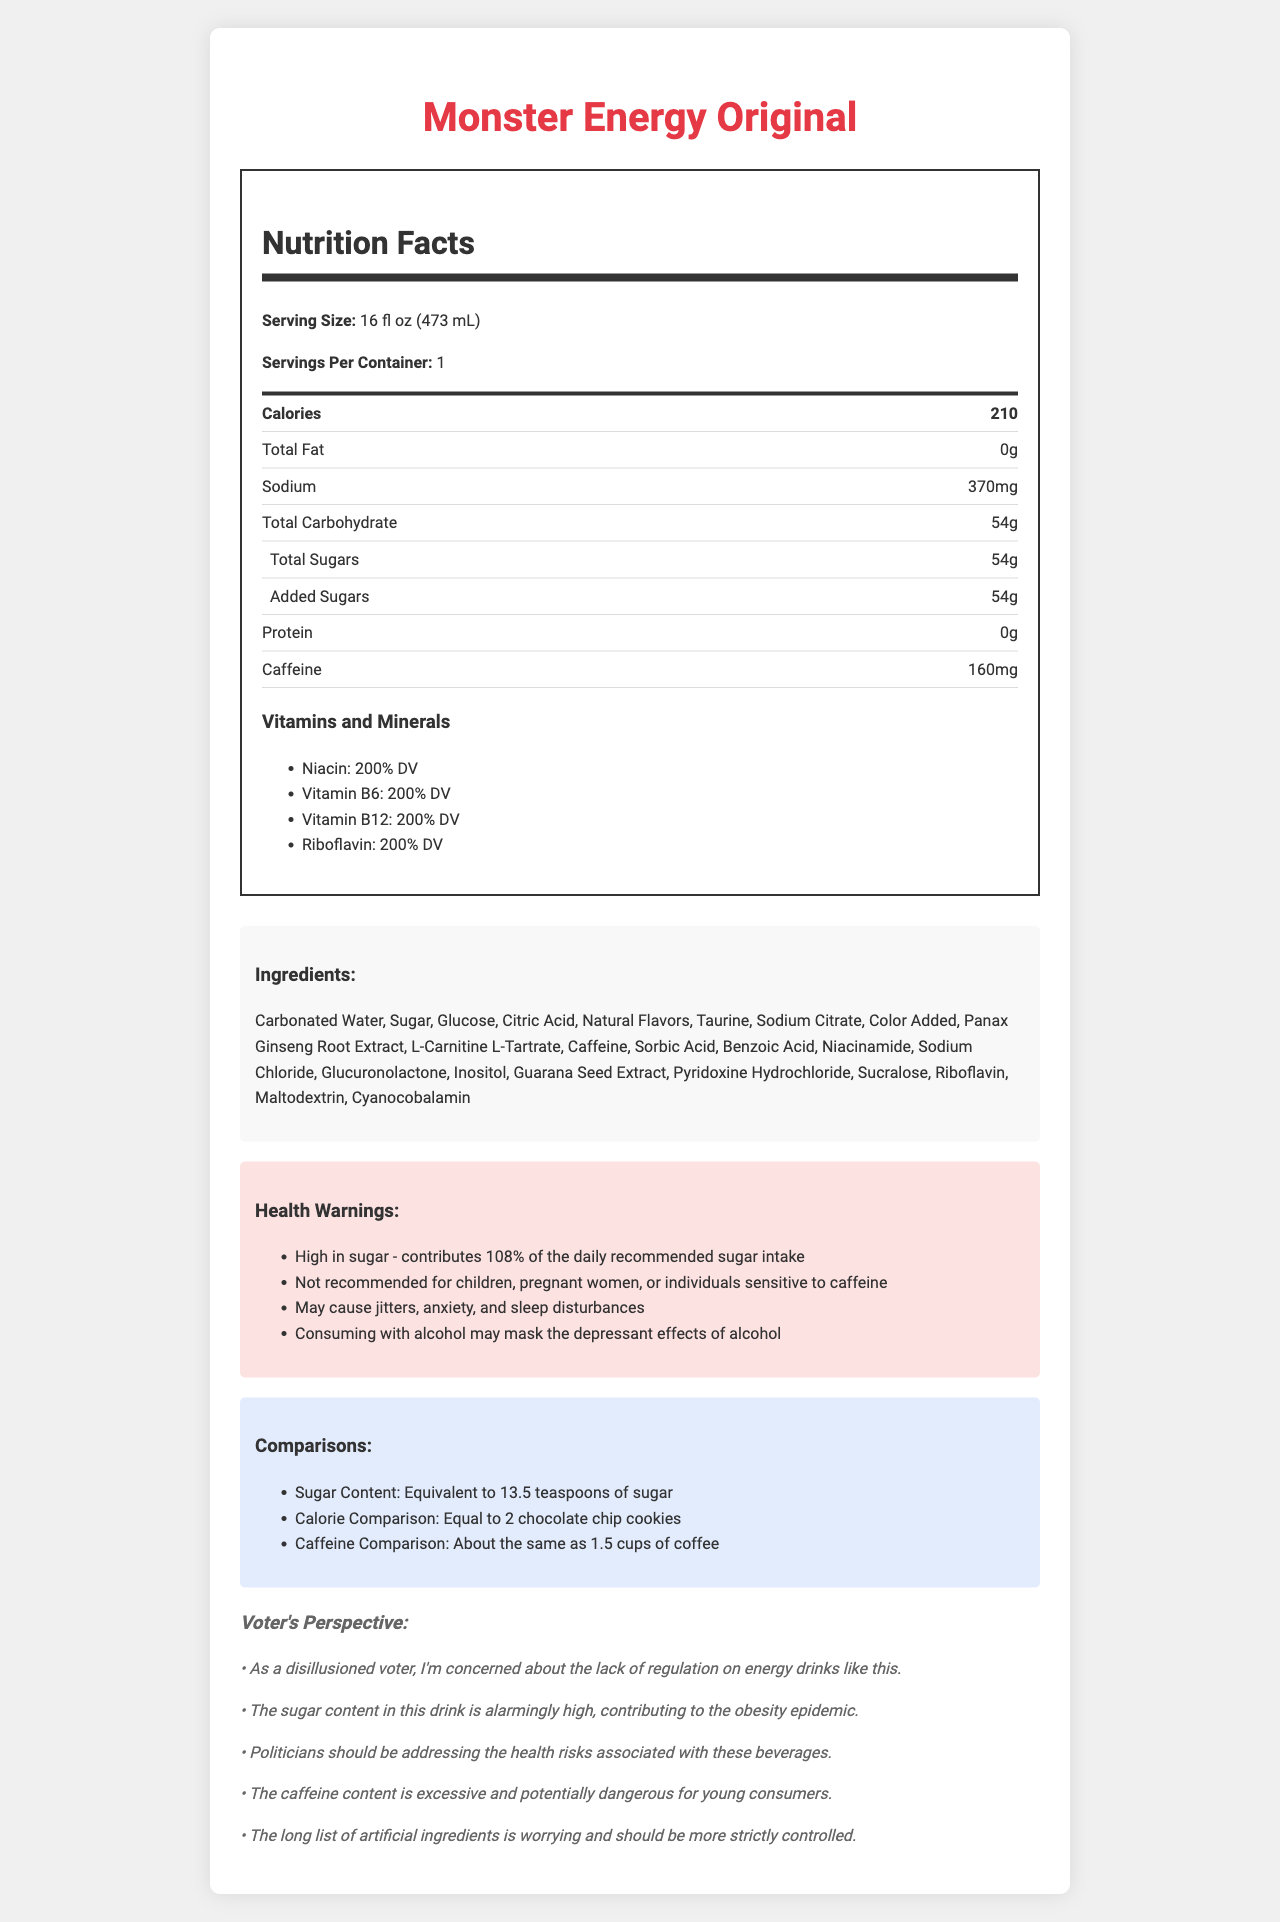What is the serving size of Monster Energy Original? The serving size is clearly stated in the Nutrition Facts section.
Answer: 16 fl oz (473 mL) How many calories are in one serving? The calories are listed prominently in the Nutrition Facts section.
Answer: 210 What is the total amount of sugars in the drink? The total sugars are indicated under the total carbohydrate in the Nutrition Facts.
Answer: 54g How much caffeine does this energy drink contain? The caffeine amount is specified in the Nutrition Facts section.
Answer: 160mg According to the document, which vitamins and minerals are at 200% of the Daily Value? These vitamins and their percentages are listed under the Vitamins and Minerals section.
Answer: Niacin, Vitamin B6, Vitamin B12, Riboflavin What is the sodium content in Monster Energy Original?
A. 200mg 
B. 370mg 
C. 500mg 
D. 150mg The sodium content is listed as 370mg in the Nutrition Facts section.
Answer: B Which ingredient is listed first for Monster Energy Original?
I. Caffeine 
II. Taurine 
III. Carbonated Water 
IV. Sugar The ingredients list starts with Carbonated Water, as it is the first entry in the Ingredients section.
Answer: III Is the sugar content of this energy drink more than 100% of the daily recommended intake? The health warnings state that the drink contributes 108% of the daily recommended sugar intake.
Answer: Yes Summarize the key points described in the document. This summary captures the main elements of the nutrition facts, ingredients, health concerns, and an overview of the voter's critical perspective.
Answer: The document provides the Nutrition Facts for Monster Energy Original, including details about its serving size, calorie count, and nutrient contents (e.g., fats, sodium, sugars, protein, and caffeine). Additionally, it highlights the significant sugar and caffeine amounts, detailed ingredients, health warnings, and comparisons of its contents to everyday items. Comments from a disillusioned voter perspective emphasize concerns about regulation, health risks, and artificial ingredients. What is the exact manufacturing cost per can of Monster Energy Original? The document does not include any information about the manufacturing costs.
Answer: Not enough information 